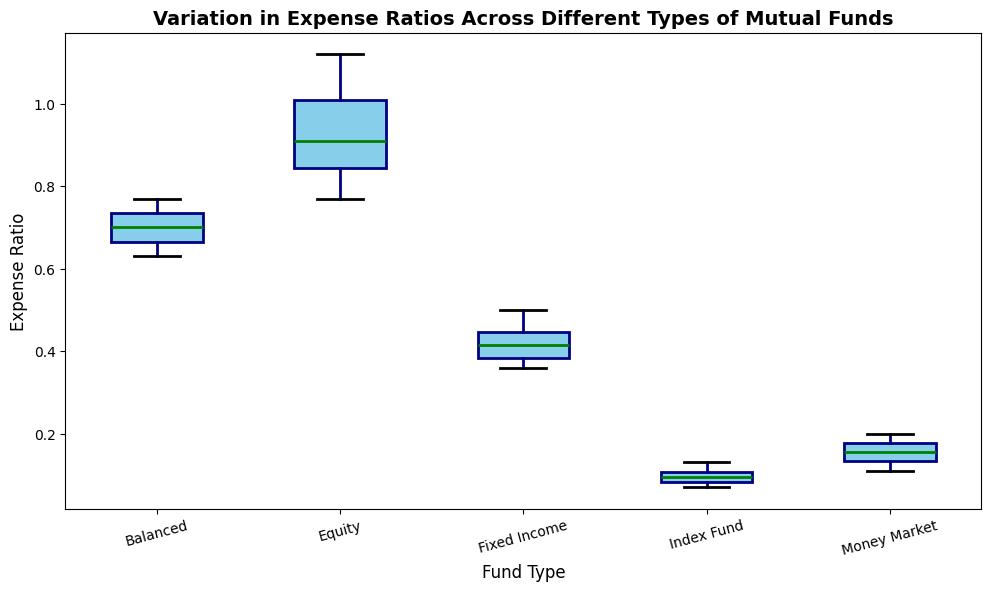What is the range of Expense Ratios for Equity funds? The range of the Expense Ratios is determined by the difference between the maximum and minimum values. From the box plot, identify the highest (1.12) and lowest (0.77) values for Equity funds. The range is 1.12 - 0.77.
Answer: 0.35 Which fund type has the highest median Expense Ratio? The median Expense Ratio can be identified by the middle line in each box. Compare the medians across all fund types to identify the highest one, which is for Equity funds.
Answer: Equity How does the variability of Expense Ratios in Equity funds compare to that in Fixed Income funds? Variability can be assessed by the interquartile range (IQR), which is the distance between the first and third quartiles (the box's height). Equity funds have a larger IQR than Fixed Income funds, indicating higher variability.
Answer: Equity funds have higher variability What are the Expense Ratios for Balanced funds outside the interquartile range? Points outside the interquartile range are represented by fliers. For Balanced funds, inspect the fliers outside the box. There are two fliers, one above (0.77) and one below (0.63).
Answer: 0.77 and 0.63 Which fund types have any outlier Expense Ratios? Outliers are displayed as individual points outside the whiskers. From the plot, identify which fund types have these points. Balanced, Money Market, and Index Fund have outliers.
Answer: Balanced, Money Market, and Index Fund Among the different fund types, which has the smallest interquartile range (IQR)? To find the smallest IQR, compare the heights of the boxes across all fund types. The Money Market funds have the smallest box height, indicating the smallest IQR.
Answer: Money Market What is the maximum Expense Ratio for Index funds? The maximum is represented by the top whisker or the highest point in the case of outliers. For Index funds, the highest value is 0.13.
Answer: 0.13 Which fund type has the lowest minimum Expense Ratio and what is it? The minimum Expense Ratio is the lowest point of the whisker or outlier. Money Market funds have the lowest minimum at 0.11.
Answer: Money Market, 0.11 How does the mean Expense Ratio of Equity funds compare to that of Fixed Income funds? Although means are not directly shown, calculate by averaging the individual Expense Ratios for each fund type from the data. The mean for Equity is higher than for Fixed Income.
Answer: Equity is higher 